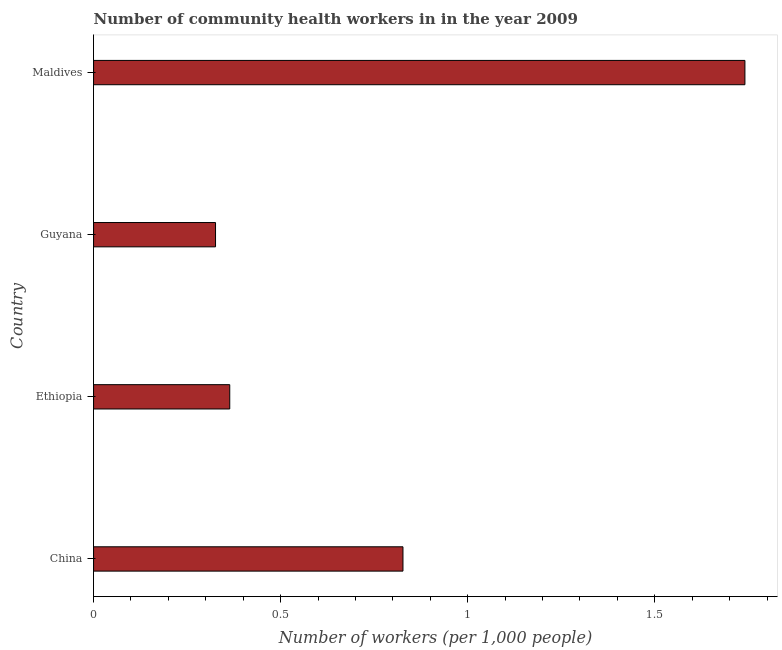Does the graph contain grids?
Offer a terse response. No. What is the title of the graph?
Give a very brief answer. Number of community health workers in in the year 2009. What is the label or title of the X-axis?
Make the answer very short. Number of workers (per 1,0 people). What is the label or title of the Y-axis?
Make the answer very short. Country. What is the number of community health workers in Guyana?
Offer a very short reply. 0.33. Across all countries, what is the maximum number of community health workers?
Keep it short and to the point. 1.74. Across all countries, what is the minimum number of community health workers?
Your answer should be very brief. 0.33. In which country was the number of community health workers maximum?
Keep it short and to the point. Maldives. In which country was the number of community health workers minimum?
Provide a succinct answer. Guyana. What is the sum of the number of community health workers?
Offer a terse response. 3.26. What is the difference between the number of community health workers in China and Ethiopia?
Offer a terse response. 0.46. What is the average number of community health workers per country?
Ensure brevity in your answer.  0.81. What is the median number of community health workers?
Make the answer very short. 0.6. What is the ratio of the number of community health workers in China to that in Ethiopia?
Your answer should be very brief. 2.27. What is the difference between the highest and the second highest number of community health workers?
Your answer should be compact. 0.91. What is the difference between the highest and the lowest number of community health workers?
Make the answer very short. 1.42. How many bars are there?
Make the answer very short. 4. How many countries are there in the graph?
Offer a terse response. 4. What is the Number of workers (per 1,000 people) in China?
Keep it short and to the point. 0.83. What is the Number of workers (per 1,000 people) of Ethiopia?
Provide a short and direct response. 0.36. What is the Number of workers (per 1,000 people) of Guyana?
Give a very brief answer. 0.33. What is the Number of workers (per 1,000 people) of Maldives?
Offer a very short reply. 1.74. What is the difference between the Number of workers (per 1,000 people) in China and Ethiopia?
Offer a very short reply. 0.46. What is the difference between the Number of workers (per 1,000 people) in China and Guyana?
Your answer should be very brief. 0.5. What is the difference between the Number of workers (per 1,000 people) in China and Maldives?
Give a very brief answer. -0.91. What is the difference between the Number of workers (per 1,000 people) in Ethiopia and Guyana?
Keep it short and to the point. 0.04. What is the difference between the Number of workers (per 1,000 people) in Ethiopia and Maldives?
Keep it short and to the point. -1.38. What is the difference between the Number of workers (per 1,000 people) in Guyana and Maldives?
Give a very brief answer. -1.42. What is the ratio of the Number of workers (per 1,000 people) in China to that in Ethiopia?
Your answer should be very brief. 2.27. What is the ratio of the Number of workers (per 1,000 people) in China to that in Guyana?
Your answer should be very brief. 2.54. What is the ratio of the Number of workers (per 1,000 people) in China to that in Maldives?
Offer a terse response. 0.47. What is the ratio of the Number of workers (per 1,000 people) in Ethiopia to that in Guyana?
Give a very brief answer. 1.12. What is the ratio of the Number of workers (per 1,000 people) in Ethiopia to that in Maldives?
Your response must be concise. 0.21. What is the ratio of the Number of workers (per 1,000 people) in Guyana to that in Maldives?
Your answer should be compact. 0.19. 